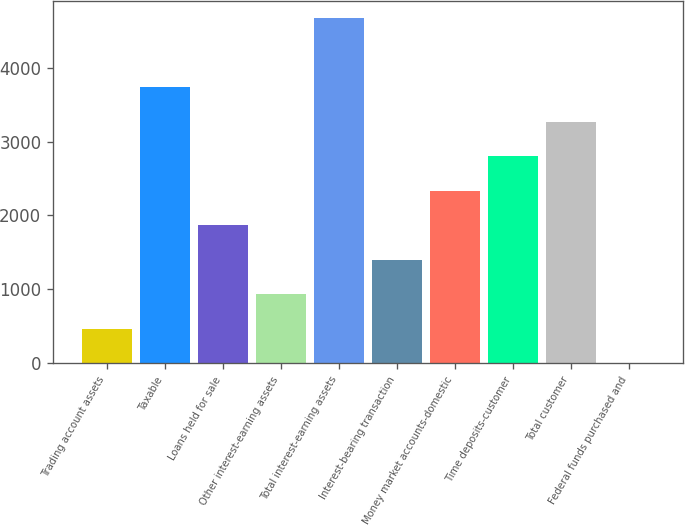Convert chart. <chart><loc_0><loc_0><loc_500><loc_500><bar_chart><fcel>Trading account assets<fcel>Taxable<fcel>Loans held for sale<fcel>Other interest-earning assets<fcel>Total interest-earning assets<fcel>Interest-bearing transaction<fcel>Money market accounts-domestic<fcel>Time deposits-customer<fcel>Total customer<fcel>Federal funds purchased and<nl><fcel>469.6<fcel>3735.8<fcel>1869.4<fcel>936.2<fcel>4669<fcel>1402.8<fcel>2336<fcel>2802.6<fcel>3269.2<fcel>3<nl></chart> 